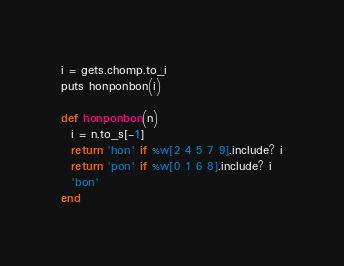Convert code to text. <code><loc_0><loc_0><loc_500><loc_500><_Ruby_>i = gets.chomp.to_i
puts honponbon(i)

def honponbon(n)
  i = n.to_s[-1]
  return 'hon' if %w[2 4 5 7 9].include? i
  return 'pon' if %w[0 1 6 8].include? i
  'bon'
end</code> 